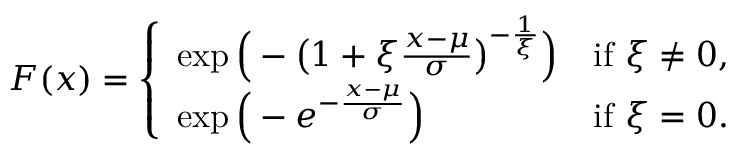Convert formula to latex. <formula><loc_0><loc_0><loc_500><loc_500>F ( x ) = { \left \{ \begin{array} { l l } { \exp { \left ( } - { \left ( } 1 + \xi { \frac { x - \mu } { \sigma } } { \right ) } ^ { - { \frac { 1 } { \xi } } } { \right ) } } & { { i f } \xi \neq 0 , } \\ { \exp { \left ( } - e ^ { - { \frac { x - \mu } { \sigma } } } { \right ) } } & { { i f } \xi = 0 . } \end{array} }</formula> 